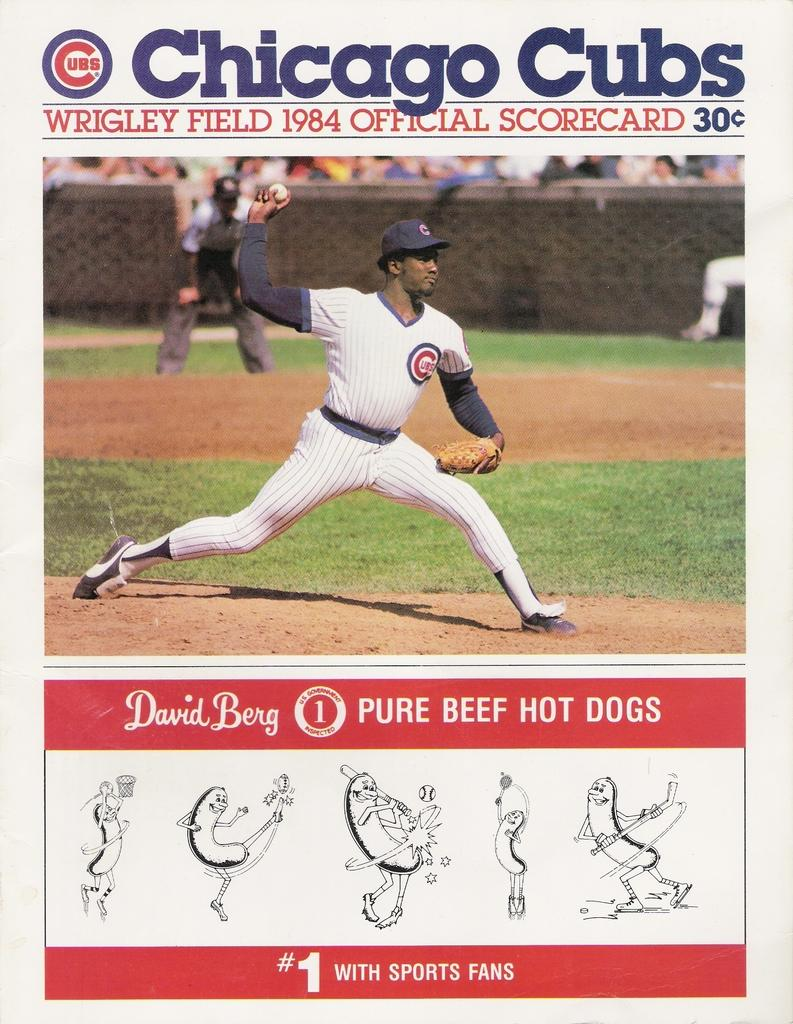<image>
Offer a succinct explanation of the picture presented. David Berg is pitching for the Chicago Cubs in 1984. 